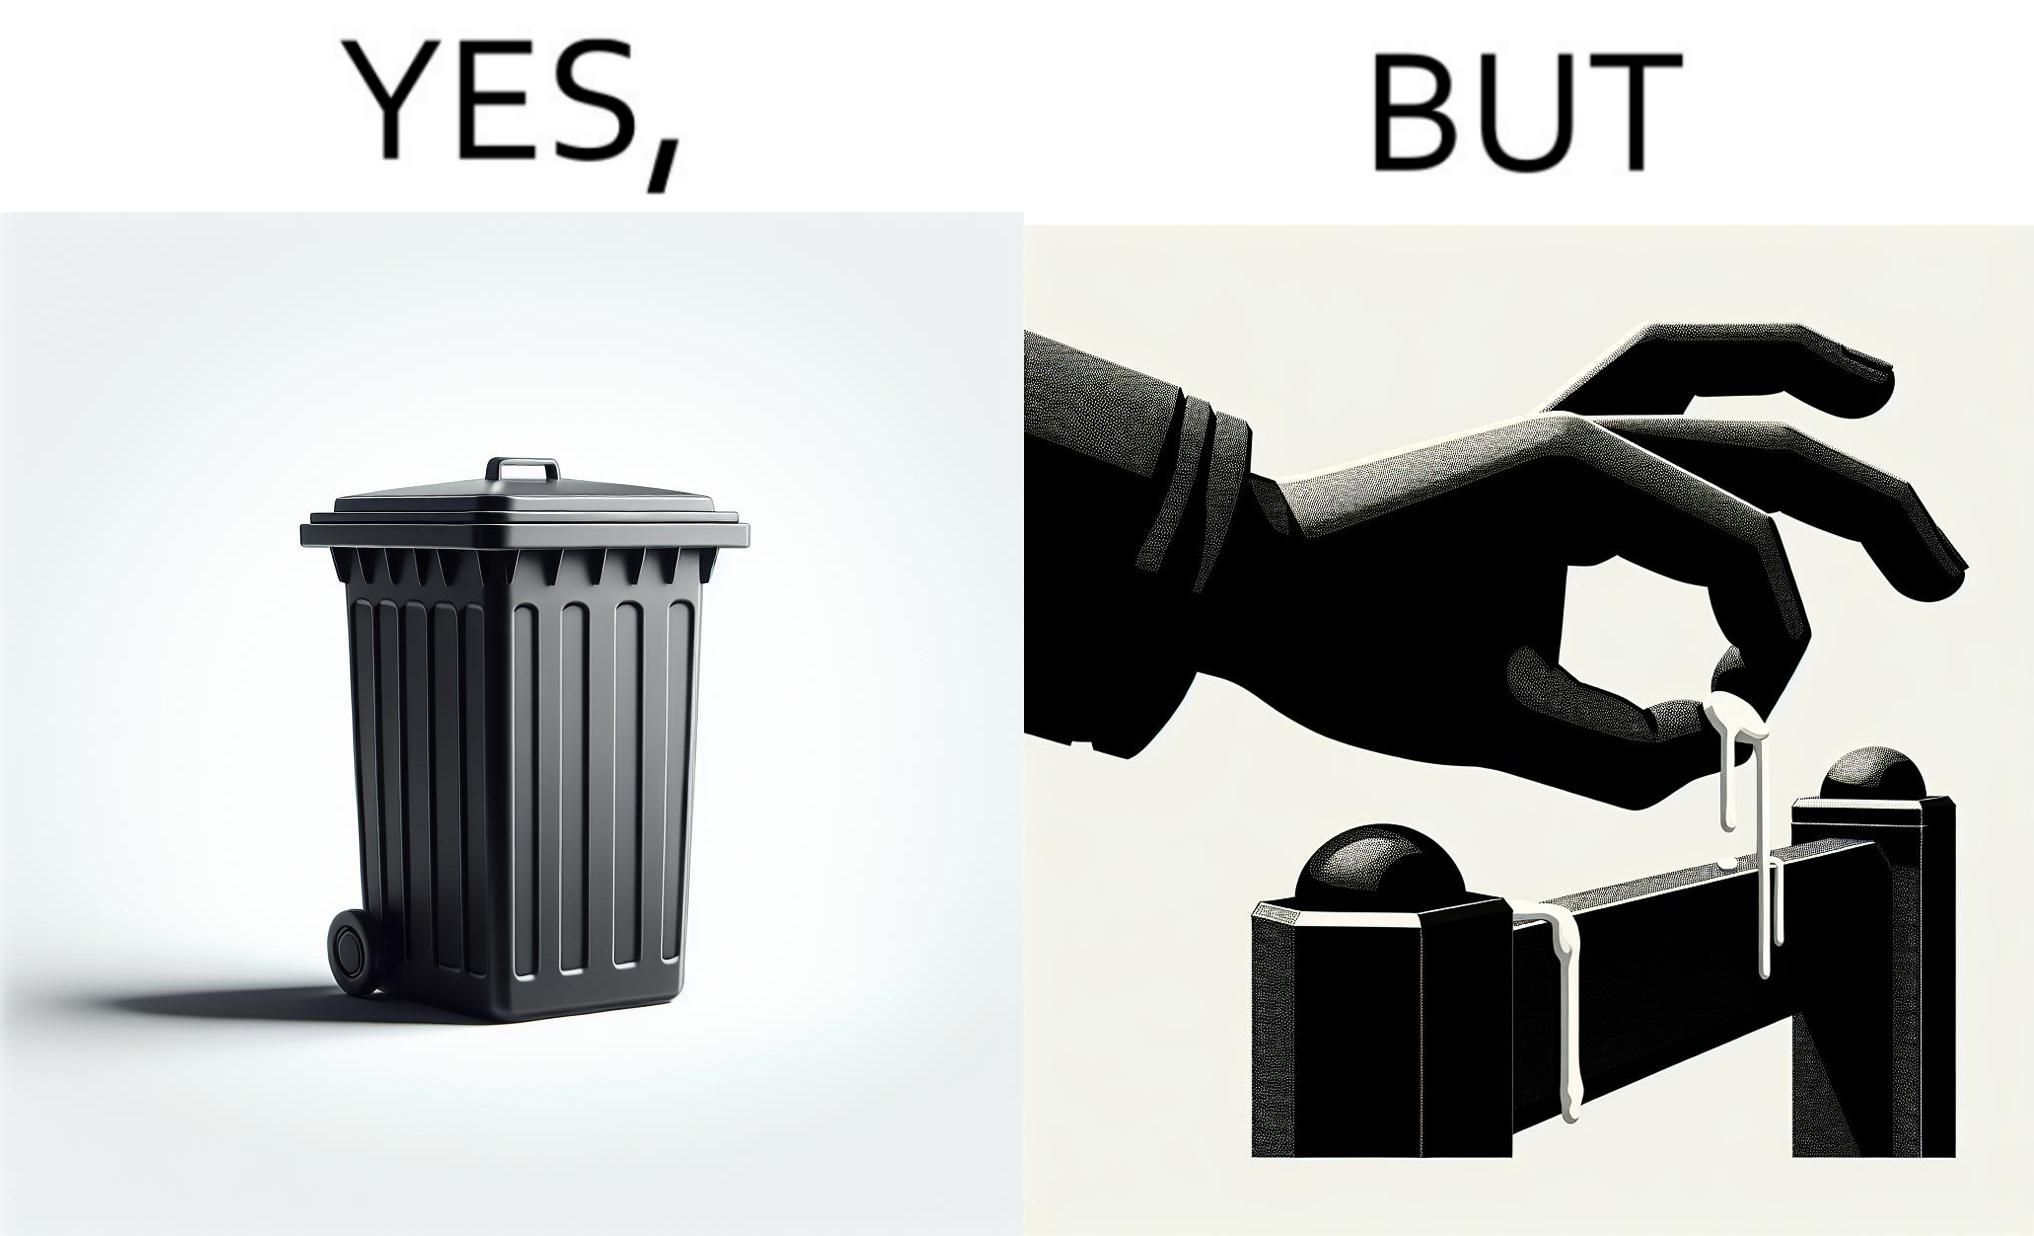Describe the content of this image. The images are ironic because even though garbage bins are provided for humans to dispose waste, by habit humans still choose to make surroundings dirty by disposing garbage improperly 